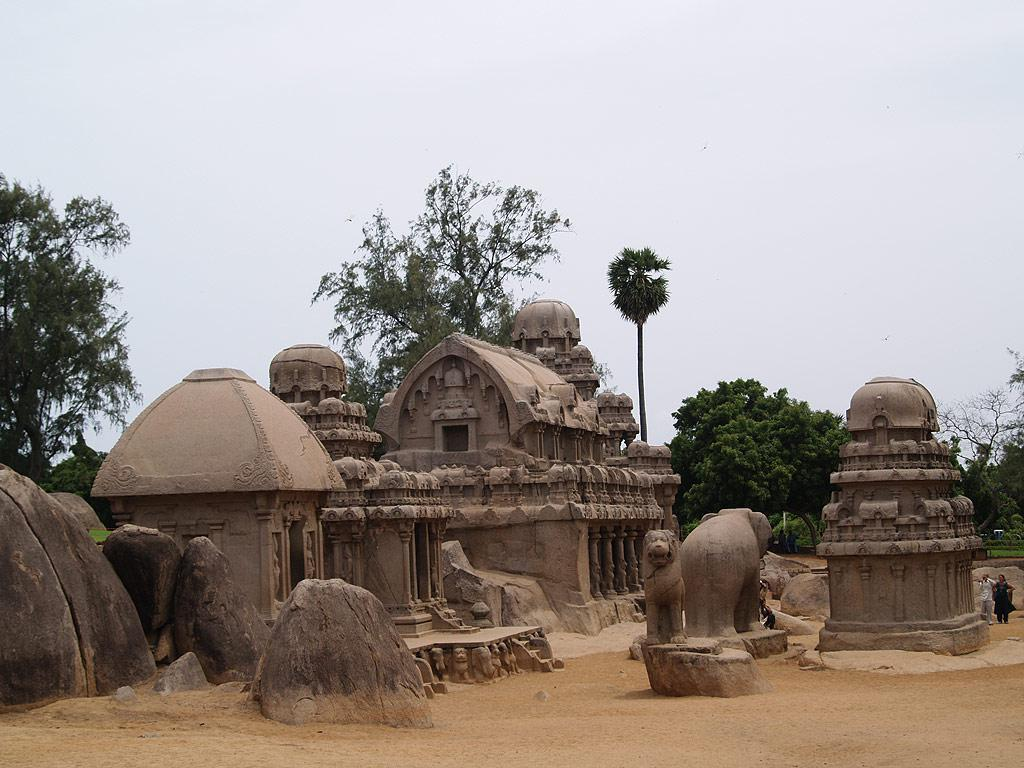What type of architecture can be seen in the image? There is ancient architecture in the image. What can be seen beneath the architecture in the image? The ground is visible in the image. Are there any living beings present in the image? Yes, there are people in the image. What other objects or structures can be seen in the image? There are statues and trees in the image. What is visible in the background of the image? The sky is visible in the background of the image. How many birds are wearing skirts in the image? There are no birds or skirts present in the image. 